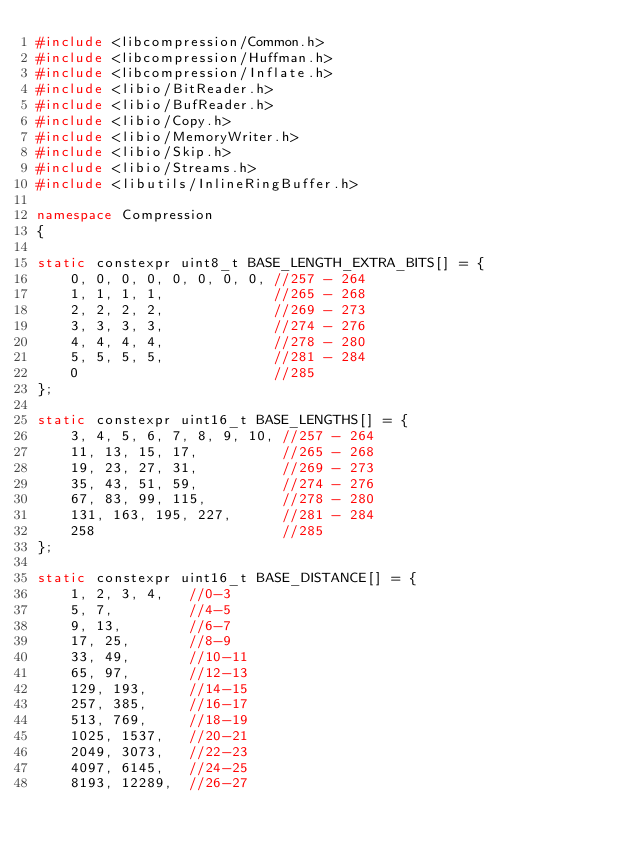Convert code to text. <code><loc_0><loc_0><loc_500><loc_500><_C++_>#include <libcompression/Common.h>
#include <libcompression/Huffman.h>
#include <libcompression/Inflate.h>
#include <libio/BitReader.h>
#include <libio/BufReader.h>
#include <libio/Copy.h>
#include <libio/MemoryWriter.h>
#include <libio/Skip.h>
#include <libio/Streams.h>
#include <libutils/InlineRingBuffer.h>

namespace Compression
{

static constexpr uint8_t BASE_LENGTH_EXTRA_BITS[] = {
    0, 0, 0, 0, 0, 0, 0, 0, //257 - 264
    1, 1, 1, 1,             //265 - 268
    2, 2, 2, 2,             //269 - 273
    3, 3, 3, 3,             //274 - 276
    4, 4, 4, 4,             //278 - 280
    5, 5, 5, 5,             //281 - 284
    0                       //285
};

static constexpr uint16_t BASE_LENGTHS[] = {
    3, 4, 5, 6, 7, 8, 9, 10, //257 - 264
    11, 13, 15, 17,          //265 - 268
    19, 23, 27, 31,          //269 - 273
    35, 43, 51, 59,          //274 - 276
    67, 83, 99, 115,         //278 - 280
    131, 163, 195, 227,      //281 - 284
    258                      //285
};

static constexpr uint16_t BASE_DISTANCE[] = {
    1, 2, 3, 4,   //0-3
    5, 7,         //4-5
    9, 13,        //6-7
    17, 25,       //8-9
    33, 49,       //10-11
    65, 97,       //12-13
    129, 193,     //14-15
    257, 385,     //16-17
    513, 769,     //18-19
    1025, 1537,   //20-21
    2049, 3073,   //22-23
    4097, 6145,   //24-25
    8193, 12289,  //26-27</code> 